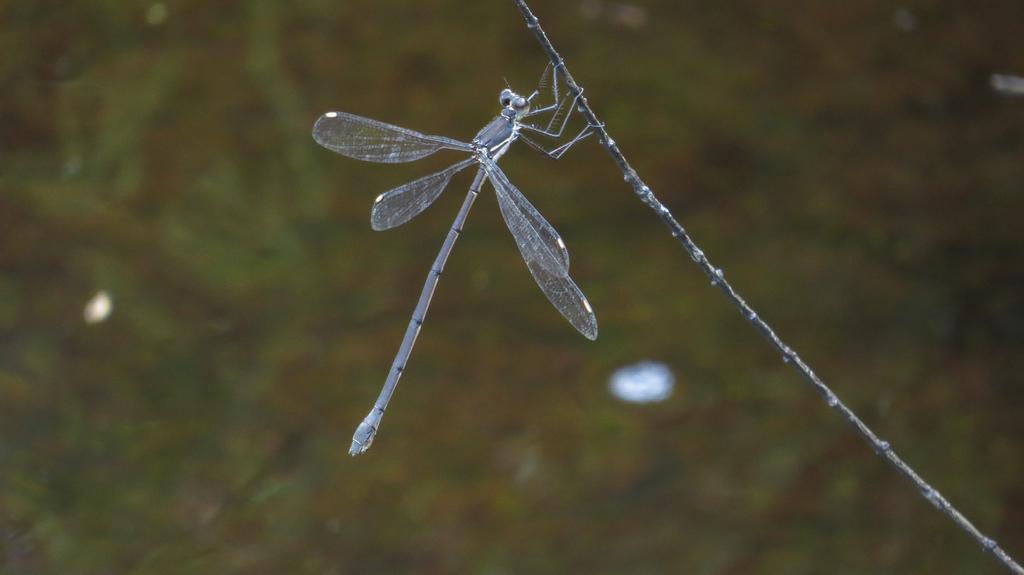In one or two sentences, can you explain what this image depicts? In this image I can see a insect visible on thread background is in green color. 